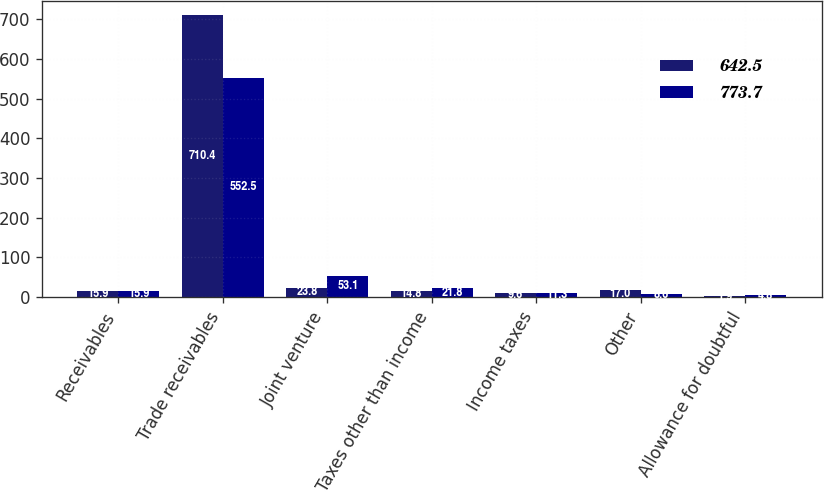Convert chart to OTSL. <chart><loc_0><loc_0><loc_500><loc_500><stacked_bar_chart><ecel><fcel>Receivables<fcel>Trade receivables<fcel>Joint venture<fcel>Taxes other than income<fcel>Income taxes<fcel>Other<fcel>Allowance for doubtful<nl><fcel>642.5<fcel>15.9<fcel>710.4<fcel>23.8<fcel>14.8<fcel>9.6<fcel>17<fcel>1.9<nl><fcel>773.7<fcel>15.9<fcel>552.5<fcel>53.1<fcel>21.8<fcel>11.3<fcel>8.6<fcel>4.8<nl></chart> 